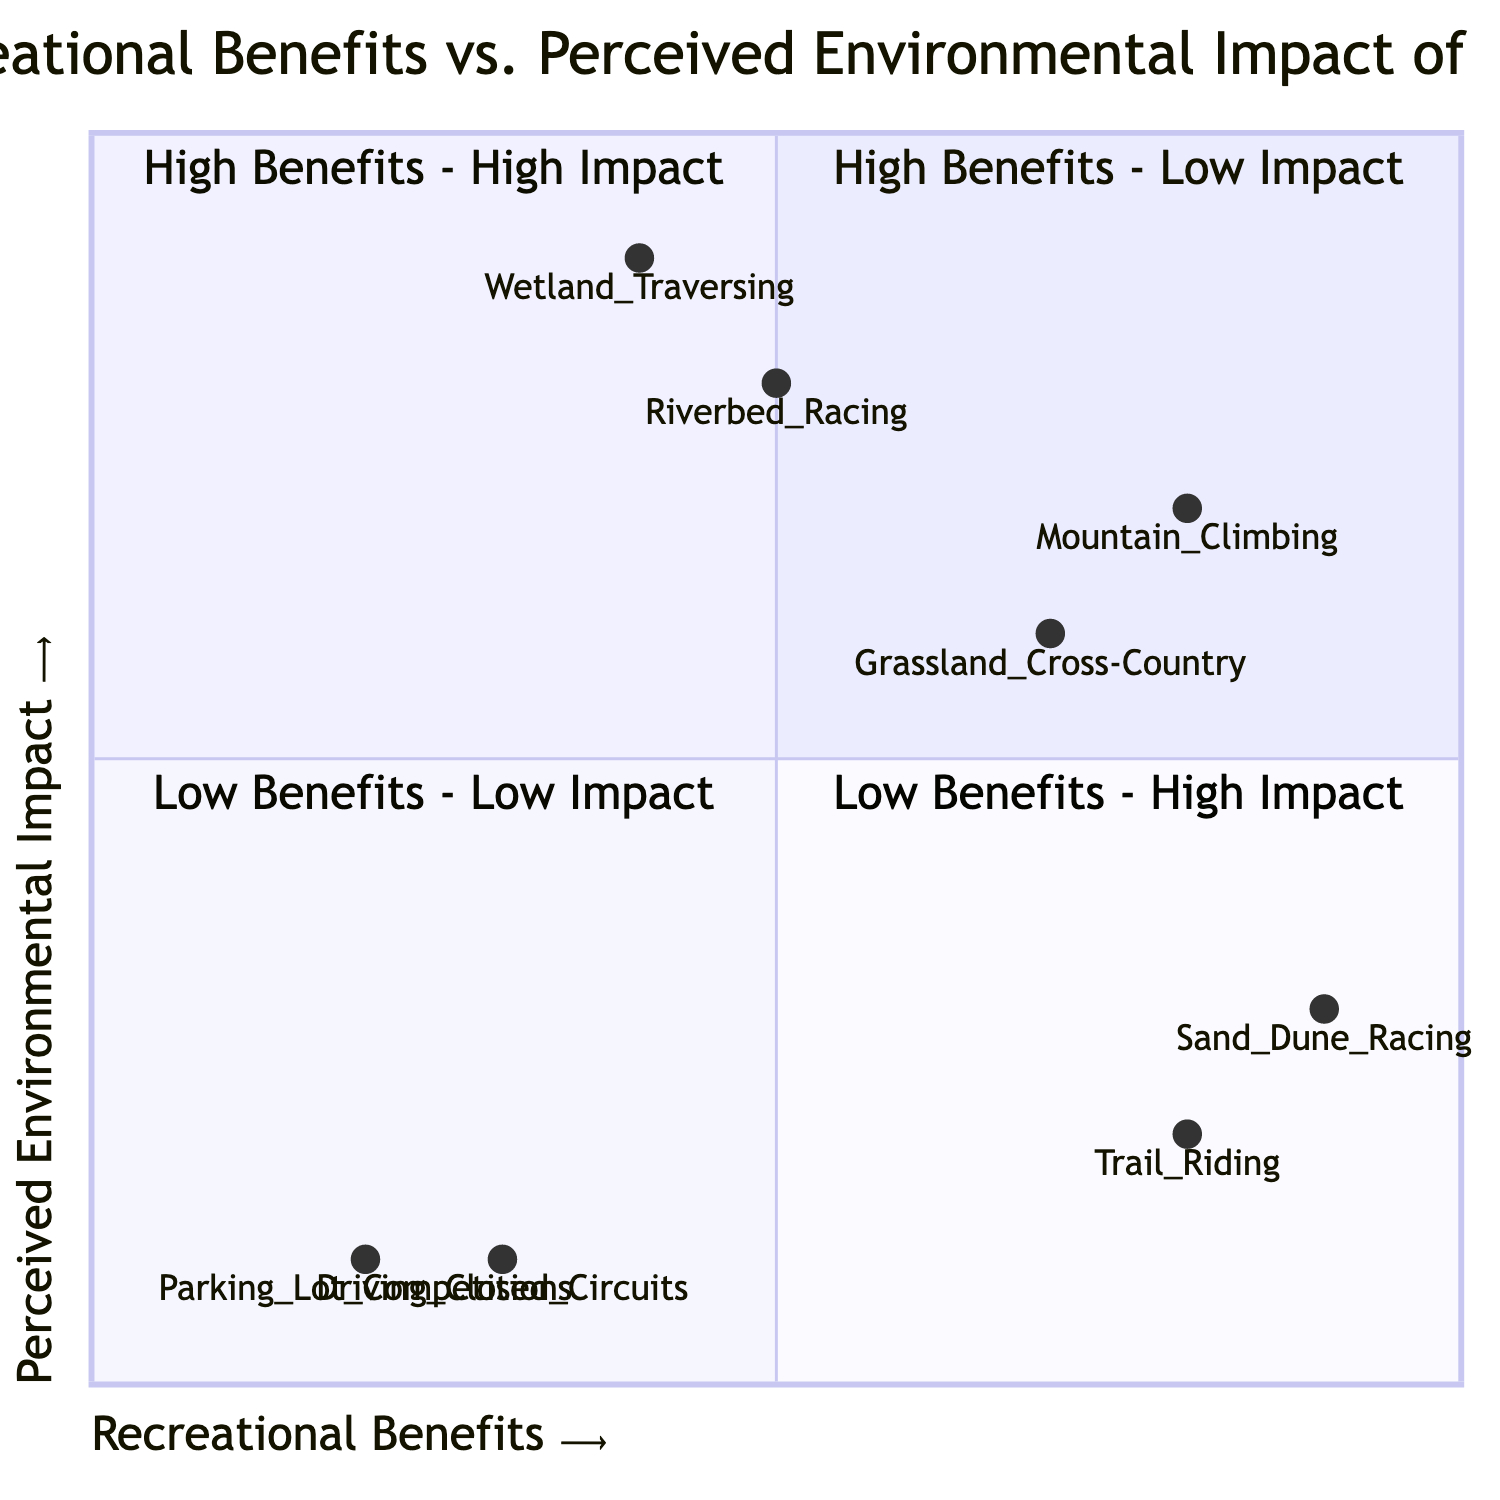What activities are in the High Benefits - Low Impact quadrant? The High Benefits - Low Impact quadrant includes "Trail Riding" and "Sand Dune Racing." These activities are located in the top-right section of the diagram, characterized by high recreational benefits and low perceived environmental impact.
Answer: Trail Riding, Sand Dune Racing Which activity has the highest recreational benefit? Among the activities listed, "Sand Dune Racing" scores 0.9 on the Recreational Benefits axis, making it the activity with the highest recreational benefit. This is compared to the other activities in the diagram.
Answer: Sand Dune Racing How many activities are in the Low Benefits - High Impact quadrant? The Low Benefits - High Impact quadrant contains two activities: "Wetland Traversing" and "Riverbed Racing." Therefore, the total number of activities in this quadrant is two.
Answer: 2 What is the perceived environmental impact of Mountain Climbing? The "Mountain Climbing" activity has a perceived environmental impact score of 0.7, indicating a high impact according to the y-axis of the quadrant. This measurement was determined by examining the specific score assigned to Mountain Climbing on the diagram.
Answer: 0.7 Which activity has the least recreational benefit? The activity with the least recreational benefit is "Parking Lot Competitions," scoring 0.2 on the x-axis (Recreational Benefits). This is the lowest score compared to other activities represented on the diagram.
Answer: Parking Lot Competitions 